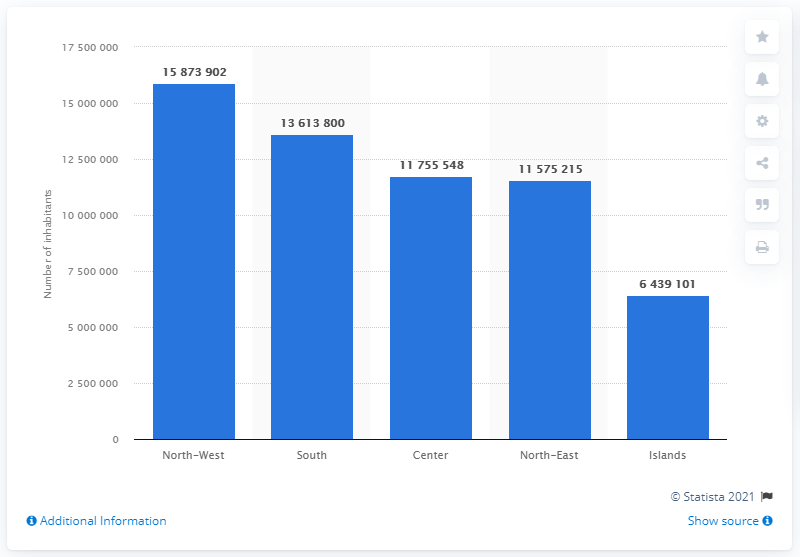Highlight a few significant elements in this photo. In January 2021, it is estimated that approximately 158,739,021 people lived in the Italian North-Western regions. In January 2021, there were approximately 64,391,010 people living in the islands. In January 2021, an estimated 1,361,380 people lived in the South of Italy. 